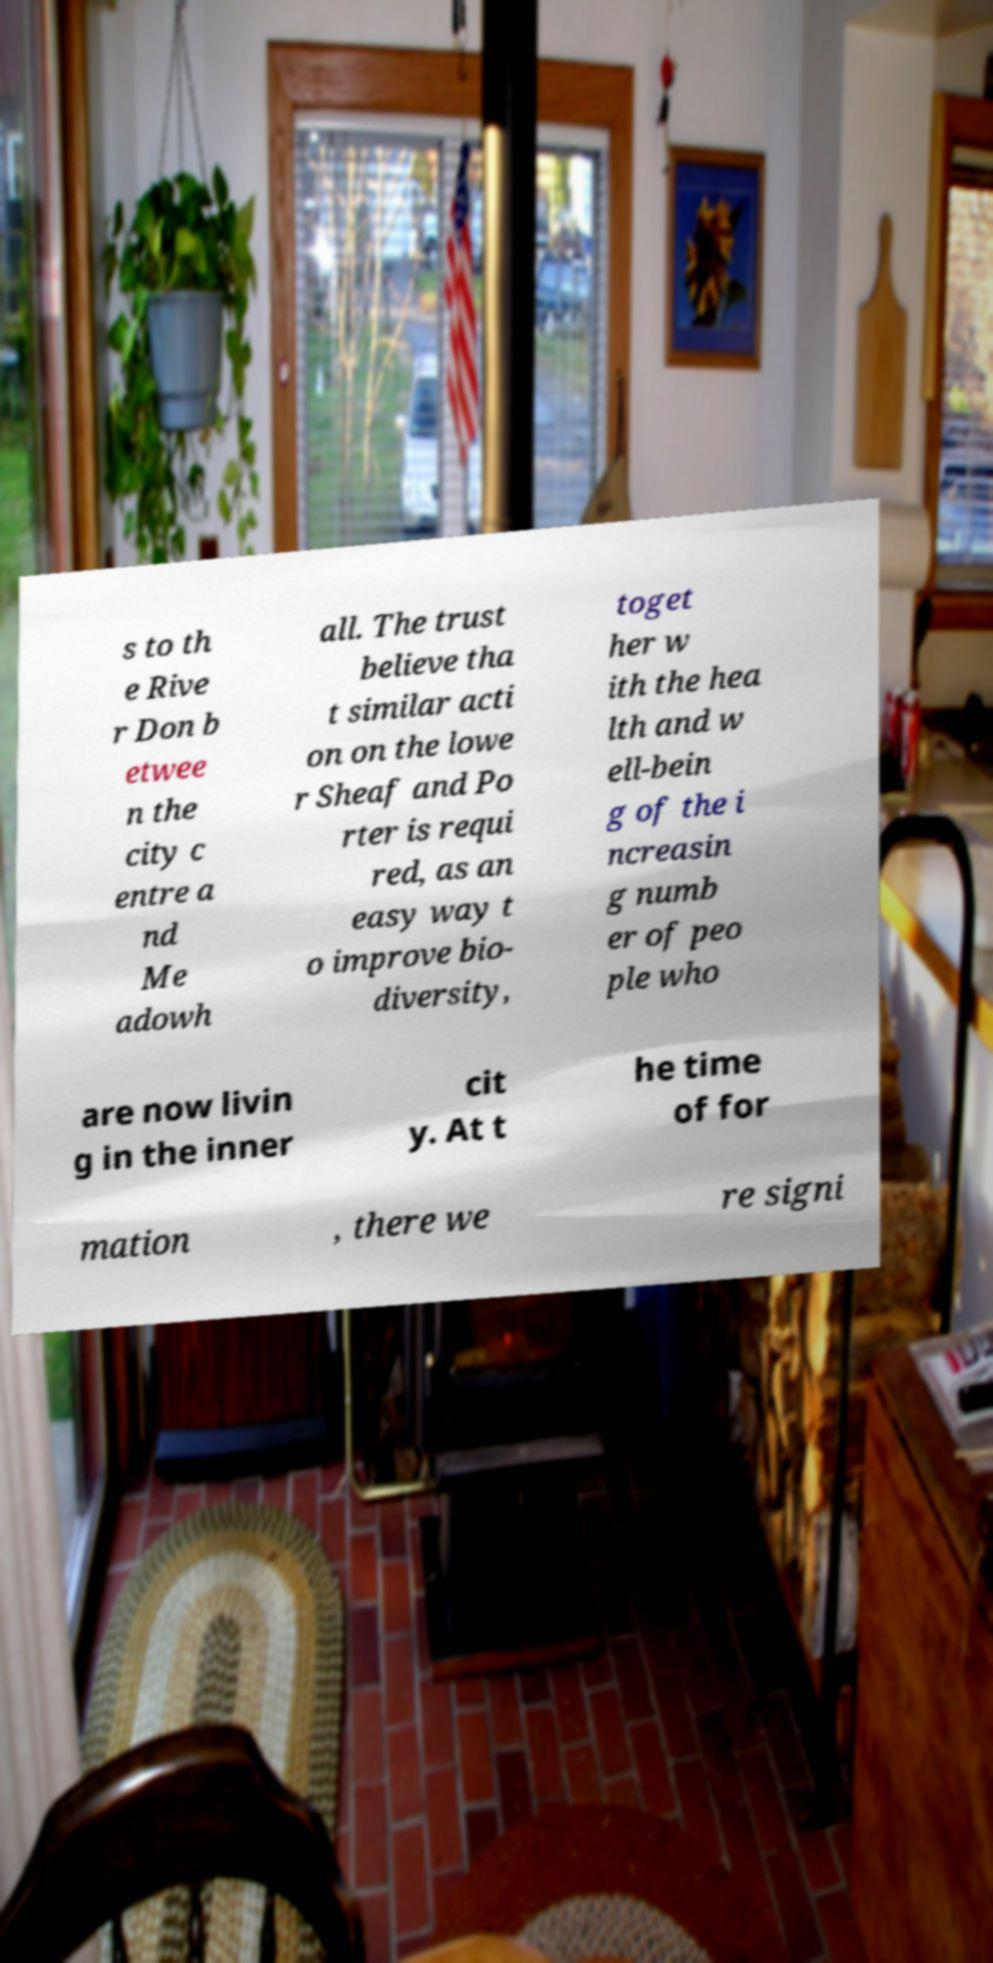Can you accurately transcribe the text from the provided image for me? s to th e Rive r Don b etwee n the city c entre a nd Me adowh all. The trust believe tha t similar acti on on the lowe r Sheaf and Po rter is requi red, as an easy way t o improve bio- diversity, toget her w ith the hea lth and w ell-bein g of the i ncreasin g numb er of peo ple who are now livin g in the inner cit y. At t he time of for mation , there we re signi 